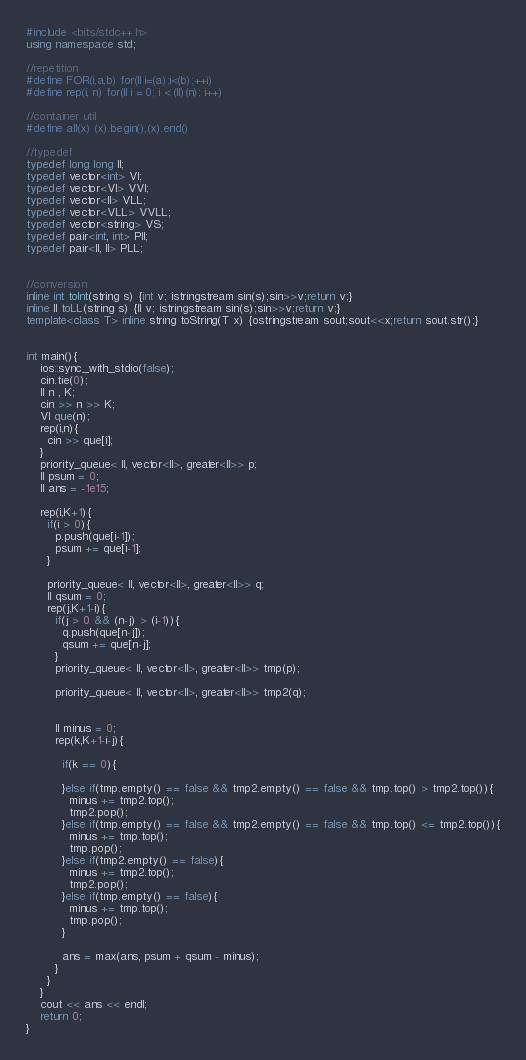<code> <loc_0><loc_0><loc_500><loc_500><_C++_>#include <bits/stdc++.h>
using namespace std;

//repetition
#define FOR(i,a,b) for(ll i=(a);i<(b);++i)
#define rep(i, n) for(ll i = 0; i < (ll)(n); i++)

//container util
#define all(x) (x).begin(),(x).end()

//typedef
typedef long long ll;
typedef vector<int> VI;
typedef vector<VI> VVI;
typedef vector<ll> VLL;
typedef vector<VLL> VVLL;
typedef vector<string> VS;
typedef pair<int, int> PII;
typedef pair<ll, ll> PLL;


//conversion
inline int toInt(string s) {int v; istringstream sin(s);sin>>v;return v;}
inline ll toLL(string s) {ll v; istringstream sin(s);sin>>v;return v;}
template<class T> inline string toString(T x) {ostringstream sout;sout<<x;return sout.str();}


int main(){
    ios::sync_with_stdio(false);
    cin.tie(0);
    ll n , K;
    cin >> n >> K;
    VI que(n);
    rep(i,n){
      cin >> que[i];
    }
    priority_queue< ll, vector<ll>, greater<ll>> p;
    ll psum = 0;
    ll ans = -1e15;

    rep(i,K+1){
      if(i > 0){
        p.push(que[i-1]);
        psum += que[i-1];
      }

      priority_queue< ll, vector<ll>, greater<ll>> q;
      ll qsum = 0;
      rep(j,K+1-i){
        if(j > 0 && (n-j) > (i-1)){
          q.push(que[n-j]);
          qsum += que[n-j];
        }
        priority_queue< ll, vector<ll>, greater<ll>> tmp(p);

        priority_queue< ll, vector<ll>, greater<ll>> tmp2(q);


        ll minus = 0;
        rep(k,K+1-i-j){

          if(k == 0){

          }else if(tmp.empty() == false && tmp2.empty() == false && tmp.top() > tmp2.top()){
            minus += tmp2.top();
            tmp2.pop();
          }else if(tmp.empty() == false && tmp2.empty() == false && tmp.top() <= tmp2.top()){
            minus += tmp.top();
            tmp.pop();
          }else if(tmp2.empty() == false){
            minus += tmp2.top();
            tmp2.pop();
          }else if(tmp.empty() == false){
            minus += tmp.top();
            tmp.pop();
          }

          ans = max(ans, psum + qsum - minus);
        }
      }
    }
    cout << ans << endl;
    return 0;
}
</code> 